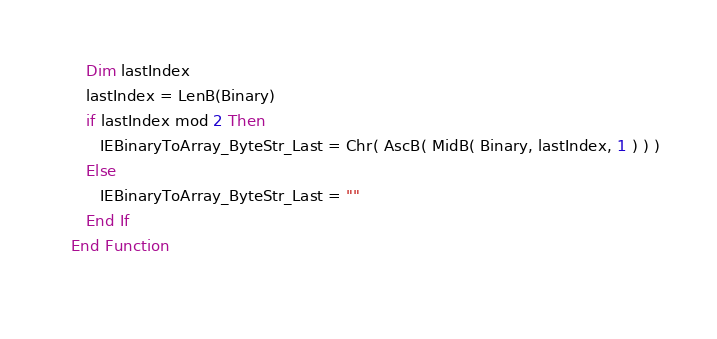Convert code to text. <code><loc_0><loc_0><loc_500><loc_500><_VisualBasic_>      Dim lastIndex
      lastIndex = LenB(Binary)
      if lastIndex mod 2 Then
         IEBinaryToArray_ByteStr_Last = Chr( AscB( MidB( Binary, lastIndex, 1 ) ) )
      Else
         IEBinaryToArray_ByteStr_Last = ""
      End If
   End Function
   </code> 